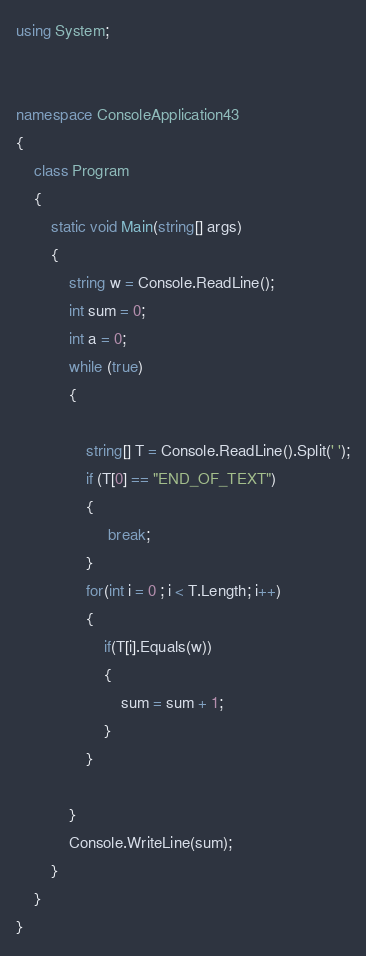Convert code to text. <code><loc_0><loc_0><loc_500><loc_500><_C#_>using System;


namespace ConsoleApplication43
{
    class Program
    {
        static void Main(string[] args)
        {
            string w = Console.ReadLine();
            int sum = 0;
            int a = 0;            
            while (true)
            {
               
                string[] T = Console.ReadLine().Split(' ');
                if (T[0] == "END_OF_TEXT")
                {
                     break;
                }
                for(int i = 0 ; i < T.Length; i++)
                {
                    if(T[i].Equals(w))
                    {
                        sum = sum + 1;
                    } 
                }
                                       
            }
            Console.WriteLine(sum);
        }
    }
}</code> 